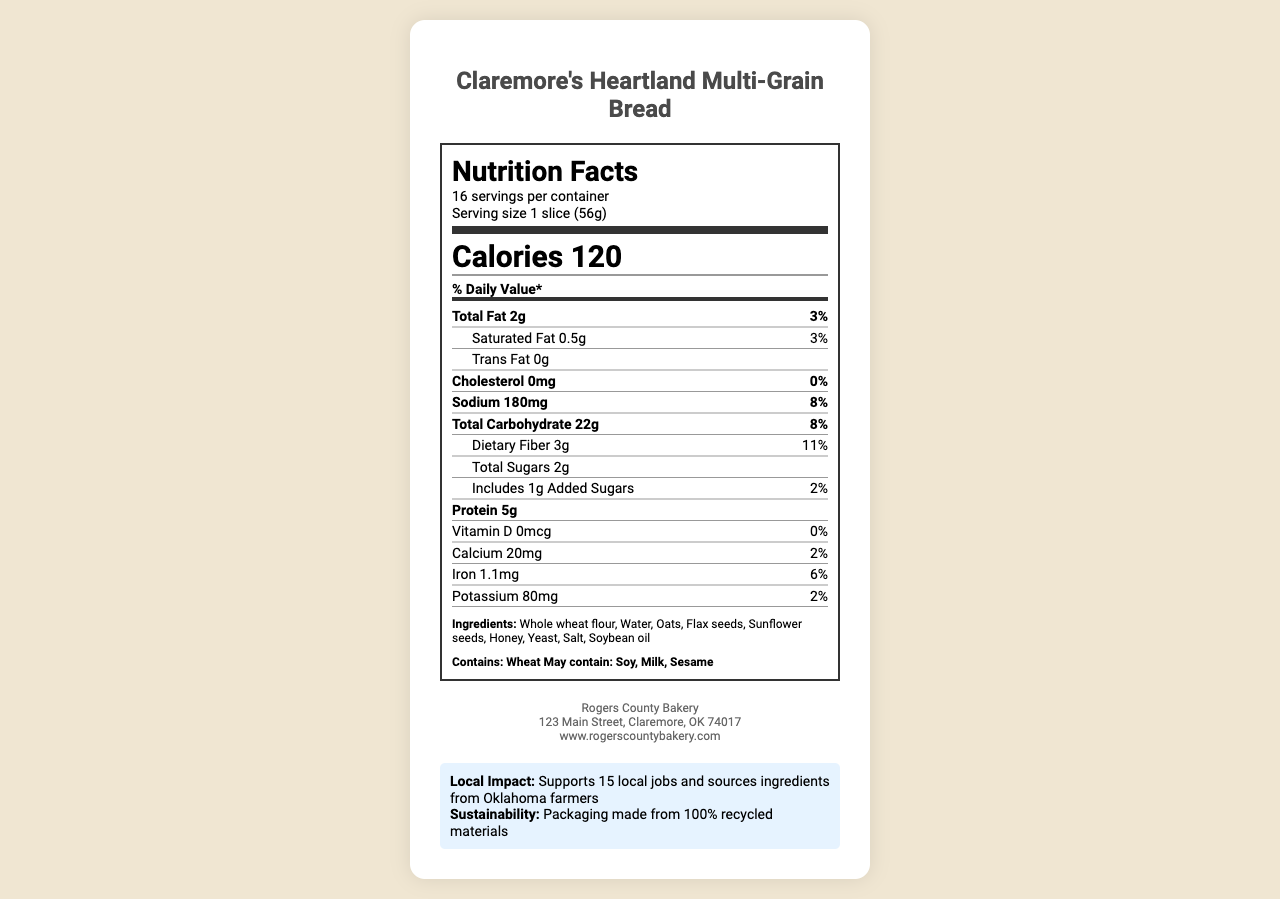what is the serving size of the bread? The serving size is mentioned in the nutrition facts label as "1 slice (56g)".
Answer: 1 slice (56g) How many servings are in one container of Claremore's Heartland Multi-Grain Bread? The document specifies "16 servings per container."
Answer: 16 What is the total fat content per serving and its daily value percentage? The label states "Total Fat 2g" and "3%" for daily value percentage.
Answer: 2g, 3% How much dietary fiber is in one serving? The nutrition facts label lists "Dietary Fiber 3g."
Answer: 3g Which three ingredients are specifically highlighted on this bread's ingredient list? The ingredient list includes whole wheat flour, water, oats, flax seeds, sunflower seeds, honey, yeast, salt, and soybean oil. The three mentioned are prominent for multi-grain breads.
Answer: Oats, flax seeds, sunflower seeds Where is the Rogers County Bakery located? The manufacturer's address is "123 Main Street, Claremore, OK 74017."
Answer: 123 Main Street, Claremore, OK 74017 How many grams of protein are in each serving of this bread? The document states, "Protein 5g."
Answer: 5g What are the allergens listed for Claremore's Heartland Multi-Grain Bread? The allergen information specifies wheat as a definite allergen and soy, milk, sesame as potential allergens.
Answer: Contains: Wheat; May contain: Soy, Milk, Sesame Which sustainable practice is mentioned in the document regarding the packaging? The sustainability statement notes that the packaging is made from 100% recycled materials.
Answer: Packaging made from 100% recycled materials How many local jobs does Rogers County Bakery support? The local economic impact statement mentions that the bakery supports 15 local jobs.
Answer: 15 local jobs What is the daily value percentage of sodium per serving? The nutrition facts label lists the sodium content as 180mg, which is equivalent to 8% of the daily value.
Answer: 8% Multiple-choice: How many grams of added sugars does each serving contain?
A. 0g
B. 1g
C. 2g
D. 3g The label notes "Includes 1g Added Sugars."
Answer: B Multiple-choice: What is the address of the Rogers County Bakery?
I. 456 High Street, Tulsa, OK 74101
II. 789 Elm Street, Bartlesville, OK 74003
III. 123 Main Street, Claremore, OK 74017
IV. 101 Pine Street, Owasso, OK 74055 The document lists the manufacturer's address as "123 Main Street, Claremore, OK 74017."
Answer: III Yes/No: Does the Claremore's Heartland Multi-Grain Bread contain trans fat? The label clearly states that the trans fat content is "0g."
Answer: No Summary: Describe the main nutritional components of Claremore's Heartland Multi-Grain Bread. This summary includes the essential breakdown of calorie count, major nutrients, and their daily values from the nutrition facts label.
Answer: Claremore's Heartland Multi-Grain Bread has 120 calories per serving and contains 2g of total fat (3% DV), 0.5g of saturated fat (3% DV), 0g of trans fat, 0mg of cholesterol (0% DV), 180mg of sodium (8% DV), 22g of total carbohydrates (8% DV), 3g of dietary fiber (11% DV), 2g of sugars, including 1g of added sugars (2% DV), and 5g of protein. Additionally, it provides small amounts of calcium, iron, and potassium. Unanswerable: What are the exact farming practices used by the Oklahoma farmers to grow the ingredients? The document does not provide details about the farming practices used by the Oklahoma farmers supplying the ingredients.
Answer: Not enough information 